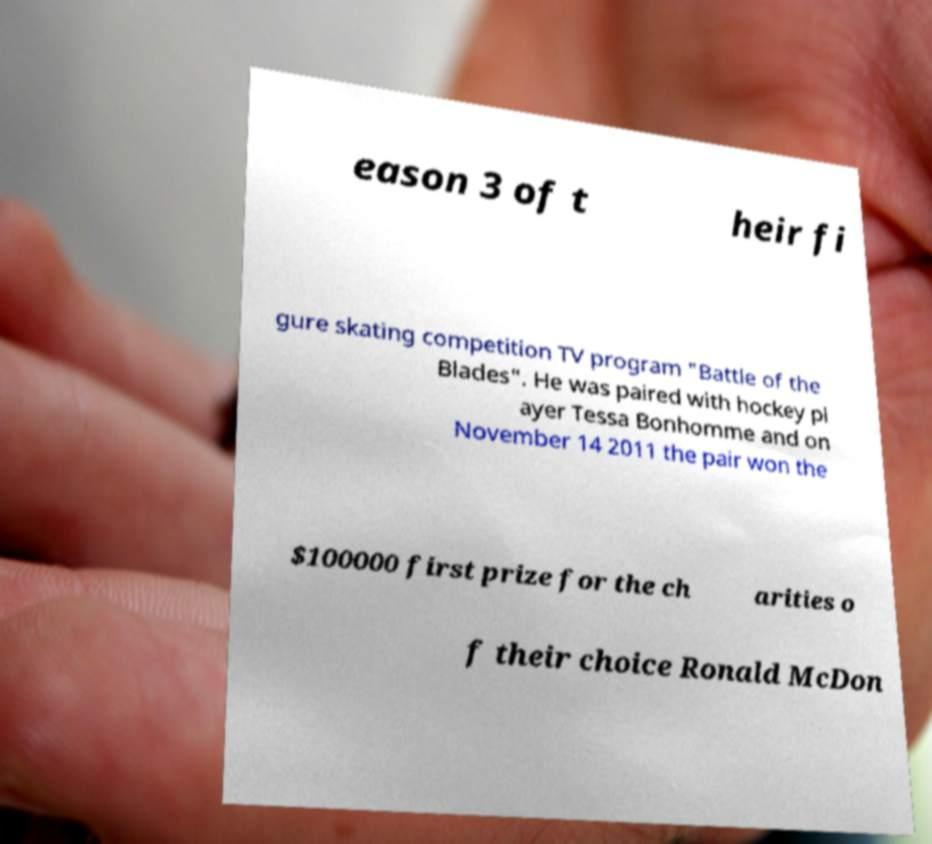Can you accurately transcribe the text from the provided image for me? eason 3 of t heir fi gure skating competition TV program "Battle of the Blades". He was paired with hockey pl ayer Tessa Bonhomme and on November 14 2011 the pair won the $100000 first prize for the ch arities o f their choice Ronald McDon 